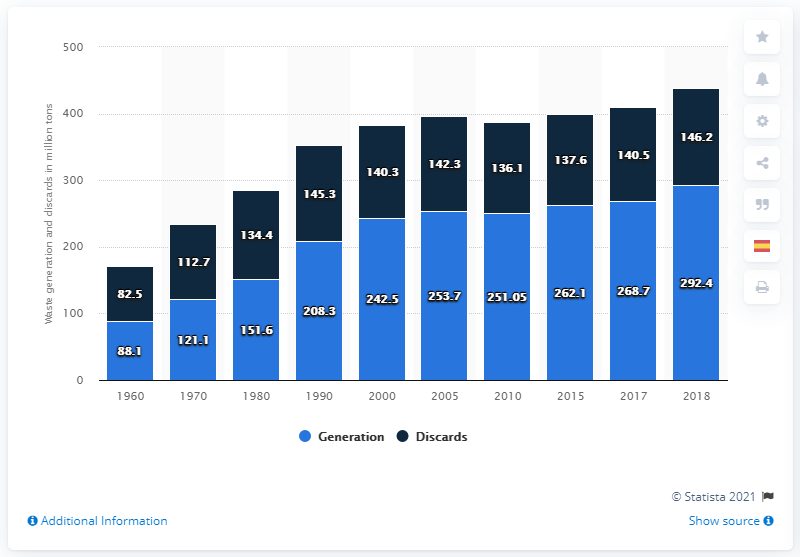Specify some key components in this picture. In 2018, the United States generated approximately 292,400 metric tons of municipal solid waste. The light blue bar represents the generation of information. In 1980, the generation and discards of 17.2.. were different. 